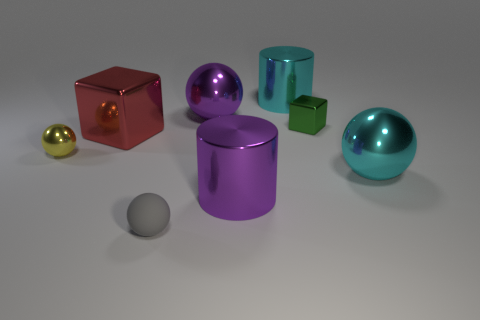There is a green thing; is its size the same as the metal sphere that is on the left side of the rubber thing?
Your answer should be compact. Yes. There is a purple thing behind the cube to the right of the large metal thing in front of the big cyan metallic ball; what size is it?
Offer a very short reply. Large. What number of metal things are either large objects or large blue balls?
Ensure brevity in your answer.  5. There is a block left of the rubber thing; what is its color?
Give a very brief answer. Red. There is a yellow object that is the same size as the gray matte thing; what shape is it?
Your answer should be compact. Sphere. How many things are either balls in front of the green metal thing or cyan shiny objects that are in front of the cyan cylinder?
Give a very brief answer. 3. There is a green block that is the same size as the gray rubber ball; what is its material?
Ensure brevity in your answer.  Metal. How many other things are there of the same material as the cyan cylinder?
Keep it short and to the point. 6. There is a yellow object that is left of the red block; does it have the same shape as the purple object that is behind the red metal thing?
Make the answer very short. Yes. What is the color of the sphere that is in front of the purple object that is on the right side of the purple object that is behind the large purple cylinder?
Keep it short and to the point. Gray. 